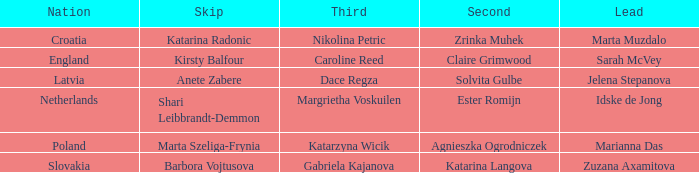Which lead has Kirsty Balfour as second? Sarah McVey. 